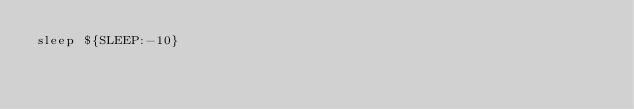Convert code to text. <code><loc_0><loc_0><loc_500><loc_500><_Bash_>sleep ${SLEEP:-10}
</code> 